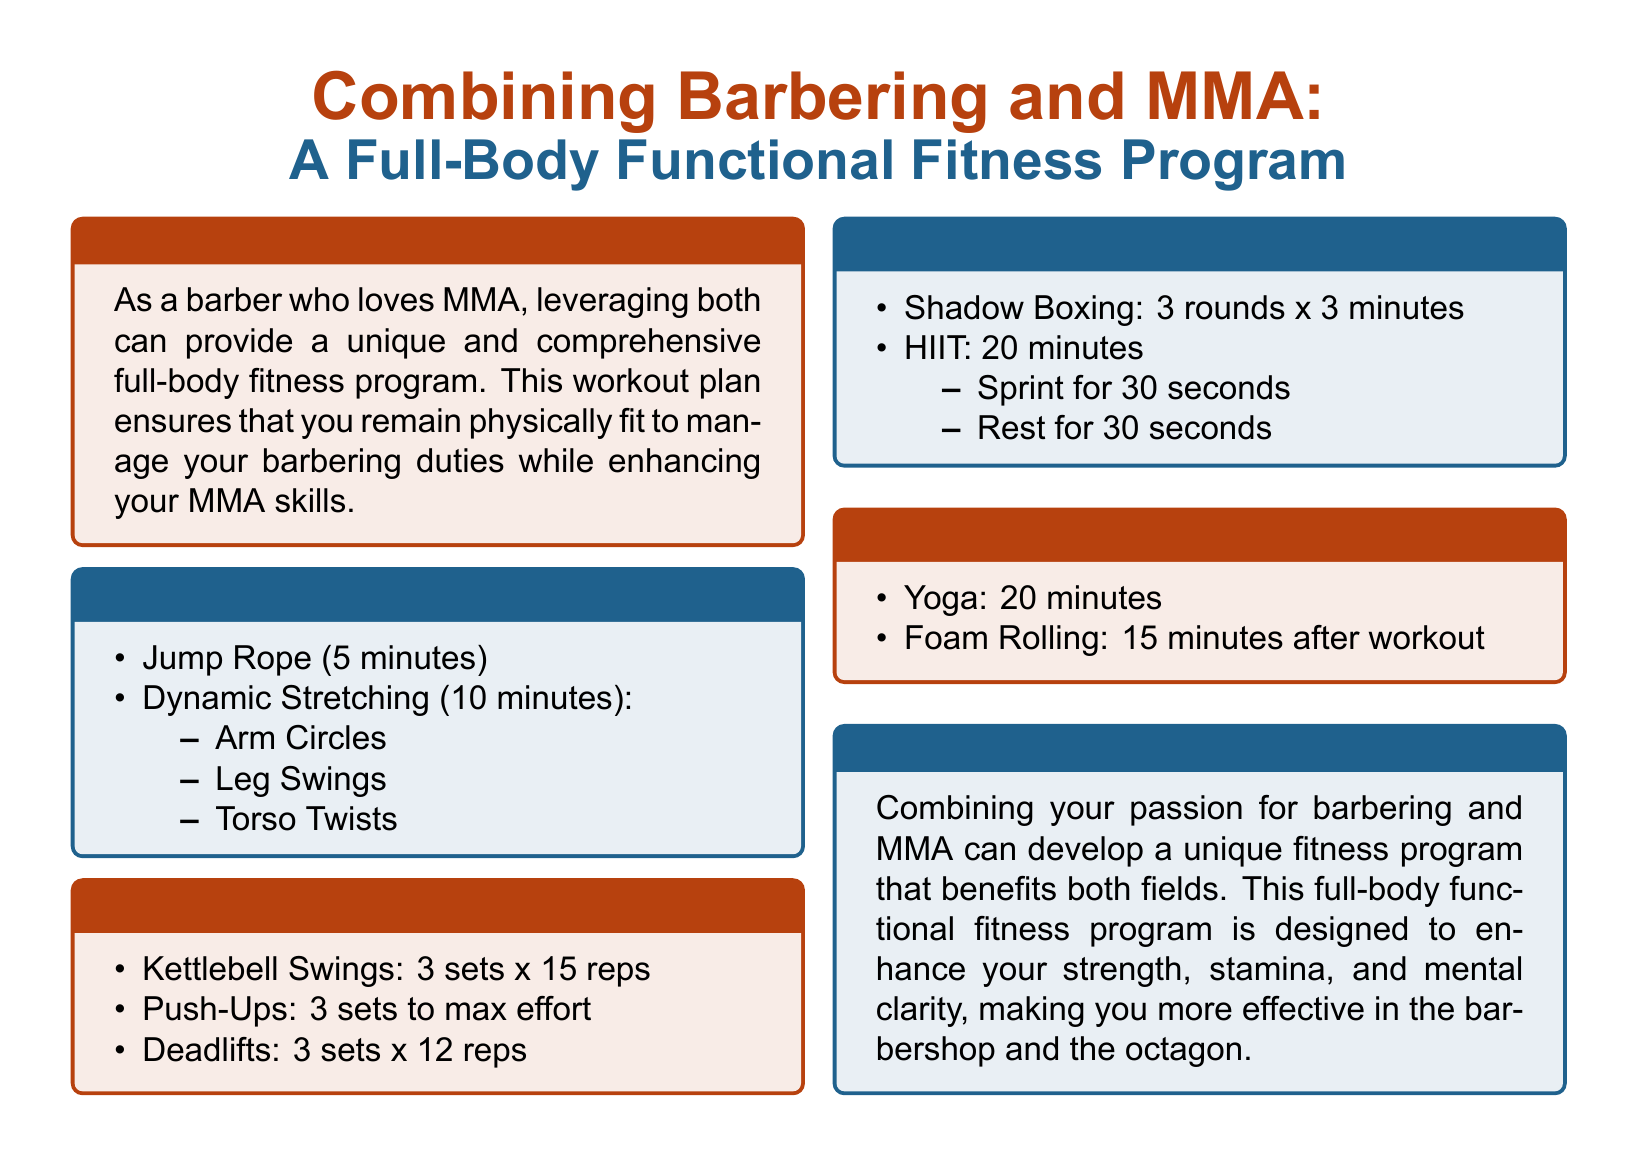what is the duration of the warm-up? The warm-up section states that it lasts for 15 minutes.
Answer: 15 minutes how many sets of kettlebell swings are included? The strength training section specifies 3 sets of kettlebell swings.
Answer: 3 sets what exercise follows shadow boxing in the cardio section? After shadow boxing, the next exercise mentioned is HIIT.
Answer: HIIT how long is the yoga session in the flexibility section? The flexibility and recovery section indicates a 20-minute yoga session.
Answer: 20 minutes what type of stretching is included in the warm-up? The warm-up section lists dynamic stretching as part of the activities.
Answer: Dynamic Stretching which workout component emphasizes both strength and function? The strength training section focuses on full-body functional exercises.
Answer: Strength Training how many reps of deadlifts are prescribed? The document states that 12 reps of deadlifts should be performed.
Answer: 12 reps what is the final activity mentioned for recovery? The final recovery activity noted is foam rolling after the workout.
Answer: Foam Rolling 